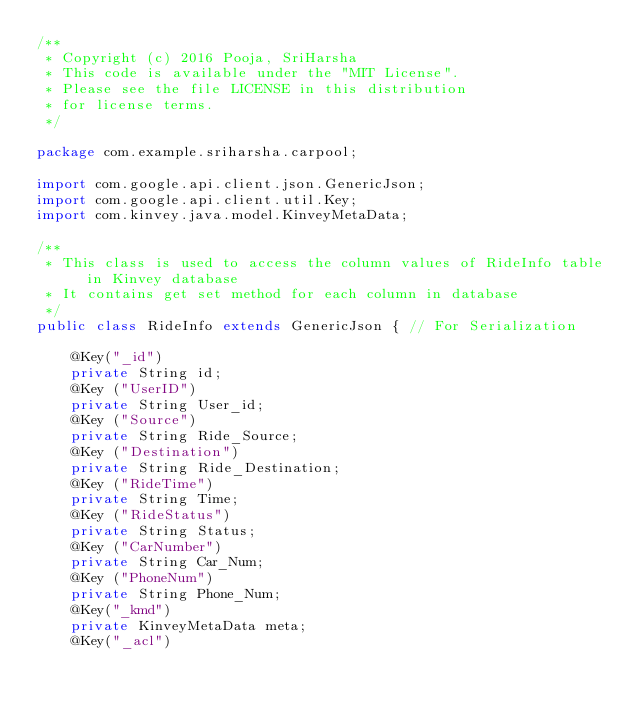<code> <loc_0><loc_0><loc_500><loc_500><_Java_>/**
 * Copyright (c) 2016 Pooja, SriHarsha
 * This code is available under the "MIT License".
 * Please see the file LICENSE in this distribution
 * for license terms.
 */

package com.example.sriharsha.carpool;

import com.google.api.client.json.GenericJson;
import com.google.api.client.util.Key;
import com.kinvey.java.model.KinveyMetaData;

/**
 * This class is used to access the column values of RideInfo table in Kinvey database
 * It contains get set method for each column in database
 */
public class RideInfo extends GenericJson { // For Serialization

    @Key("_id")
    private String id;
    @Key ("UserID")
    private String User_id;
    @Key ("Source")
    private String Ride_Source;
    @Key ("Destination")
    private String Ride_Destination;
    @Key ("RideTime")
    private String Time;
    @Key ("RideStatus")
    private String Status;
    @Key ("CarNumber")
    private String Car_Num;
    @Key ("PhoneNum")
    private String Phone_Num;
    @Key("_kmd")
    private KinveyMetaData meta;
    @Key("_acl")</code> 